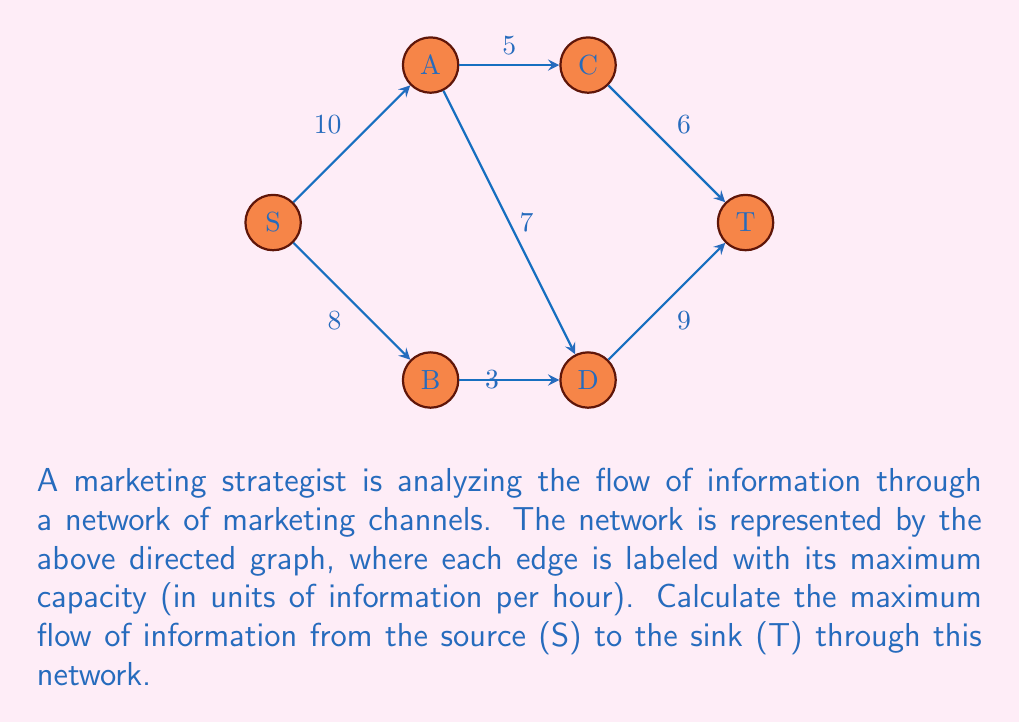Could you help me with this problem? To solve this maximum flow problem, we'll use the Ford-Fulkerson algorithm:

1) Initialize flow to 0 for all edges.

2) Find an augmenting path from S to T:
   Path 1: S -> A -> C -> T (min capacity = 5)
   Increase flow by 5
   Residual graph:
   S -> A: 5/10
   A -> C: 5/5
   C -> T: 5/6

3) Find another augmenting path:
   Path 2: S -> A -> D -> T (min capacity = 5)
   Increase flow by 5
   Residual graph:
   S -> A: 10/10
   A -> D: 5/7
   D -> T: 5/9

4) Find another augmenting path:
   Path 3: S -> B -> D -> T (min capacity = 3)
   Increase flow by 3
   Residual graph:
   S -> B: 3/8
   B -> D: 3/3
   D -> T: 8/9

5) No more augmenting paths exist.

The maximum flow is the sum of all flow increases:
$$5 + 5 + 3 = 13$$

Therefore, the maximum flow of information through this network is 13 units per hour.
Answer: 13 units per hour 